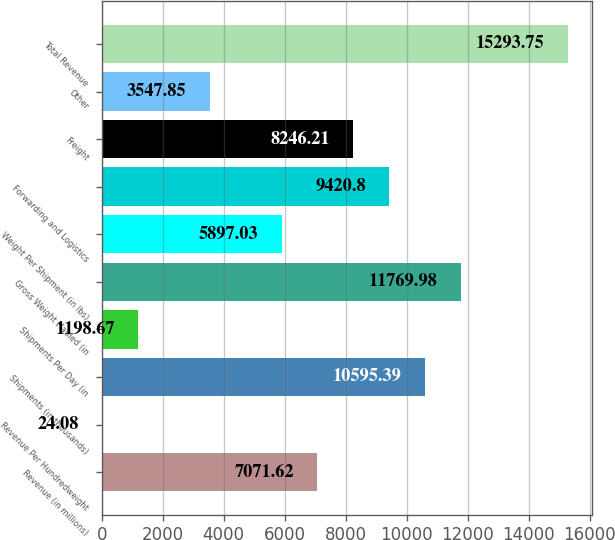<chart> <loc_0><loc_0><loc_500><loc_500><bar_chart><fcel>Revenue (in millions)<fcel>Revenue Per Hundredweight<fcel>Shipments (in thousands)<fcel>Shipments Per Day (in<fcel>Gross Weight Hauled (in<fcel>Weight Per Shipment (in lbs)<fcel>Forwarding and Logistics<fcel>Freight<fcel>Other<fcel>Total Revenue<nl><fcel>7071.62<fcel>24.08<fcel>10595.4<fcel>1198.67<fcel>11770<fcel>5897.03<fcel>9420.8<fcel>8246.21<fcel>3547.85<fcel>15293.8<nl></chart> 